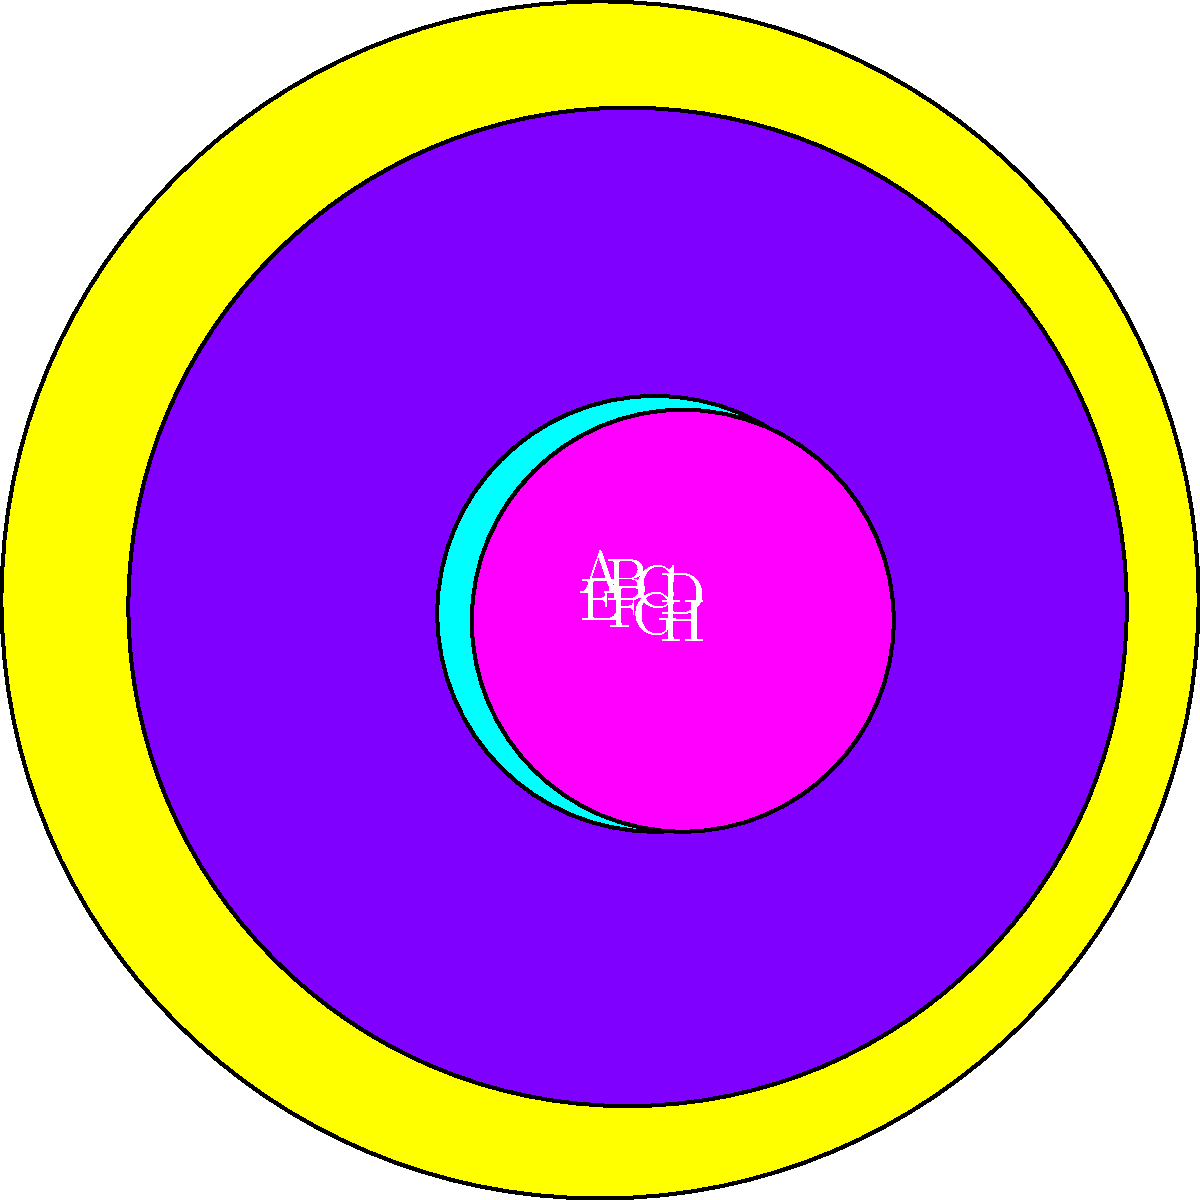In this tactile representation of planets in our solar system, eight circles are arranged in two rows, each labeled with a letter from A to H. The sizes of the circles correspond to the relative sizes of the planets. Which letter represents the largest planet in our solar system? To determine the largest planet, we need to compare the sizes of the circles:

1. Feel the sizes of all circles, noting their relative diameters.
2. The largest circle will represent the largest planet.
3. Jupiter is the largest planet in our solar system.
4. In this representation, the largest circle is labeled E.

Therefore, the letter E represents the largest planet, which is Jupiter.
Answer: E 